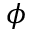<formula> <loc_0><loc_0><loc_500><loc_500>\phi</formula> 